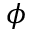<formula> <loc_0><loc_0><loc_500><loc_500>\phi</formula> 